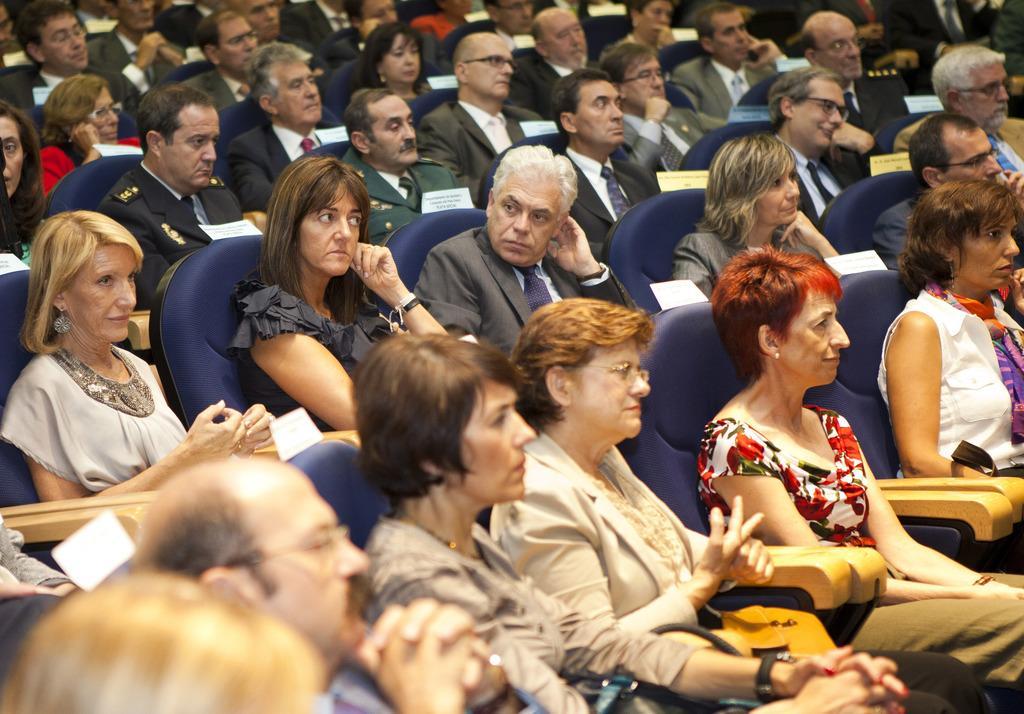Please provide a concise description of this image. In this image we can see a group of people wearing dress are sitting on chairs. In the background, we can see some papers with some text are pasted on the chairs. 